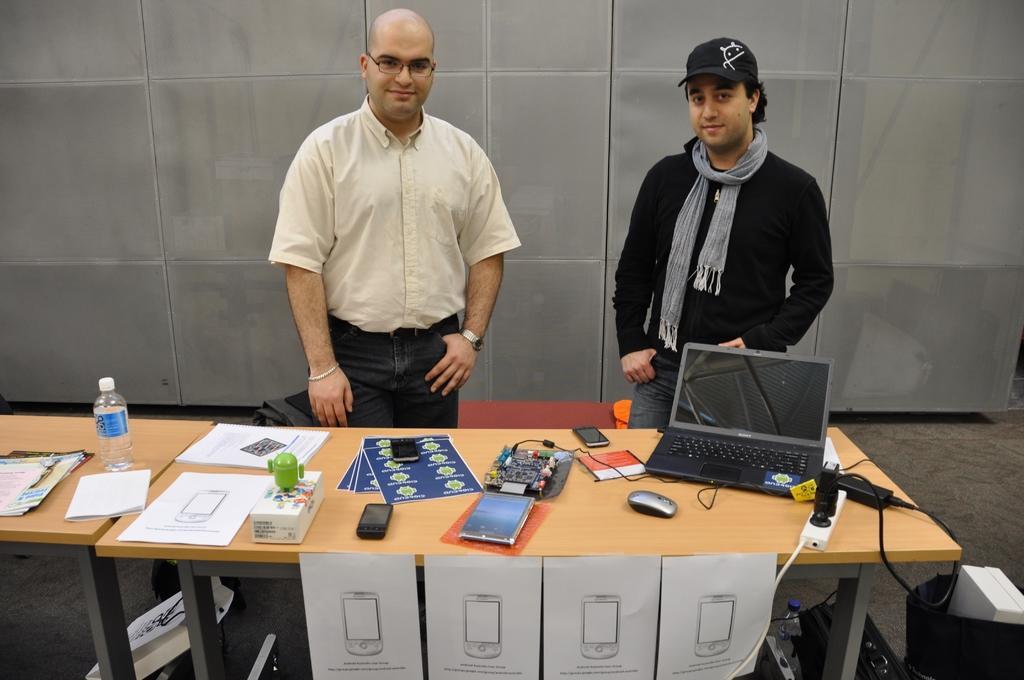How would you summarize this image in a sentence or two? In this image, there are two persons standing behind this table. This table contains switch board, laptop, three mobile phones, box, water bottle and some papers. There are two bags on the ground. There is a switchboard and water bottle on the ground. This person wearing spectacles and watch. This person wearing scarf and cap. 